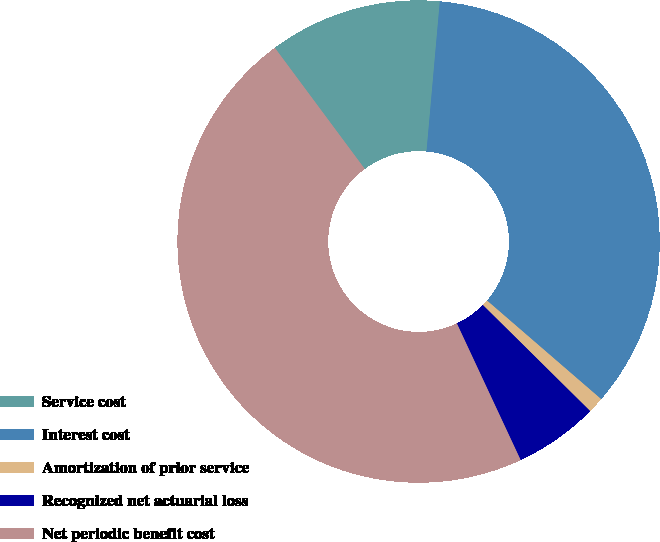<chart> <loc_0><loc_0><loc_500><loc_500><pie_chart><fcel>Service cost<fcel>Interest cost<fcel>Amortization of prior service<fcel>Recognized net actuarial loss<fcel>Net periodic benefit cost<nl><fcel>11.57%<fcel>34.93%<fcel>1.07%<fcel>5.64%<fcel>46.79%<nl></chart> 